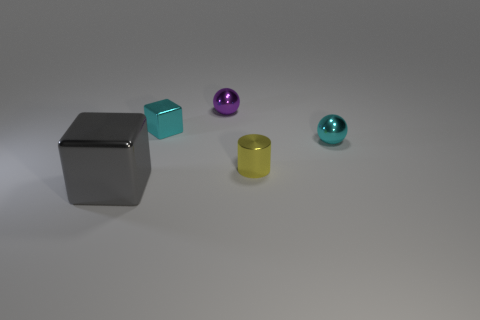Are there any other things that are the same shape as the yellow thing?
Your response must be concise. No. What material is the tiny purple ball?
Make the answer very short. Metal. What is the shape of the cyan object right of the ball behind the cyan metallic ball?
Ensure brevity in your answer.  Sphere. What number of other things are the same shape as the gray object?
Your answer should be very brief. 1. There is a tiny purple metallic sphere; are there any metallic things to the right of it?
Give a very brief answer. Yes. What color is the metal cylinder?
Give a very brief answer. Yellow. There is a small shiny cube; is its color the same as the metal sphere on the right side of the tiny purple ball?
Keep it short and to the point. Yes. Is there a brown shiny sphere that has the same size as the cylinder?
Provide a succinct answer. No. What is the block that is in front of the tiny cyan shiny block made of?
Provide a short and direct response. Metal. Is the number of small cyan balls that are behind the cyan metallic cube the same as the number of shiny cubes that are behind the small metallic cylinder?
Offer a very short reply. No. 